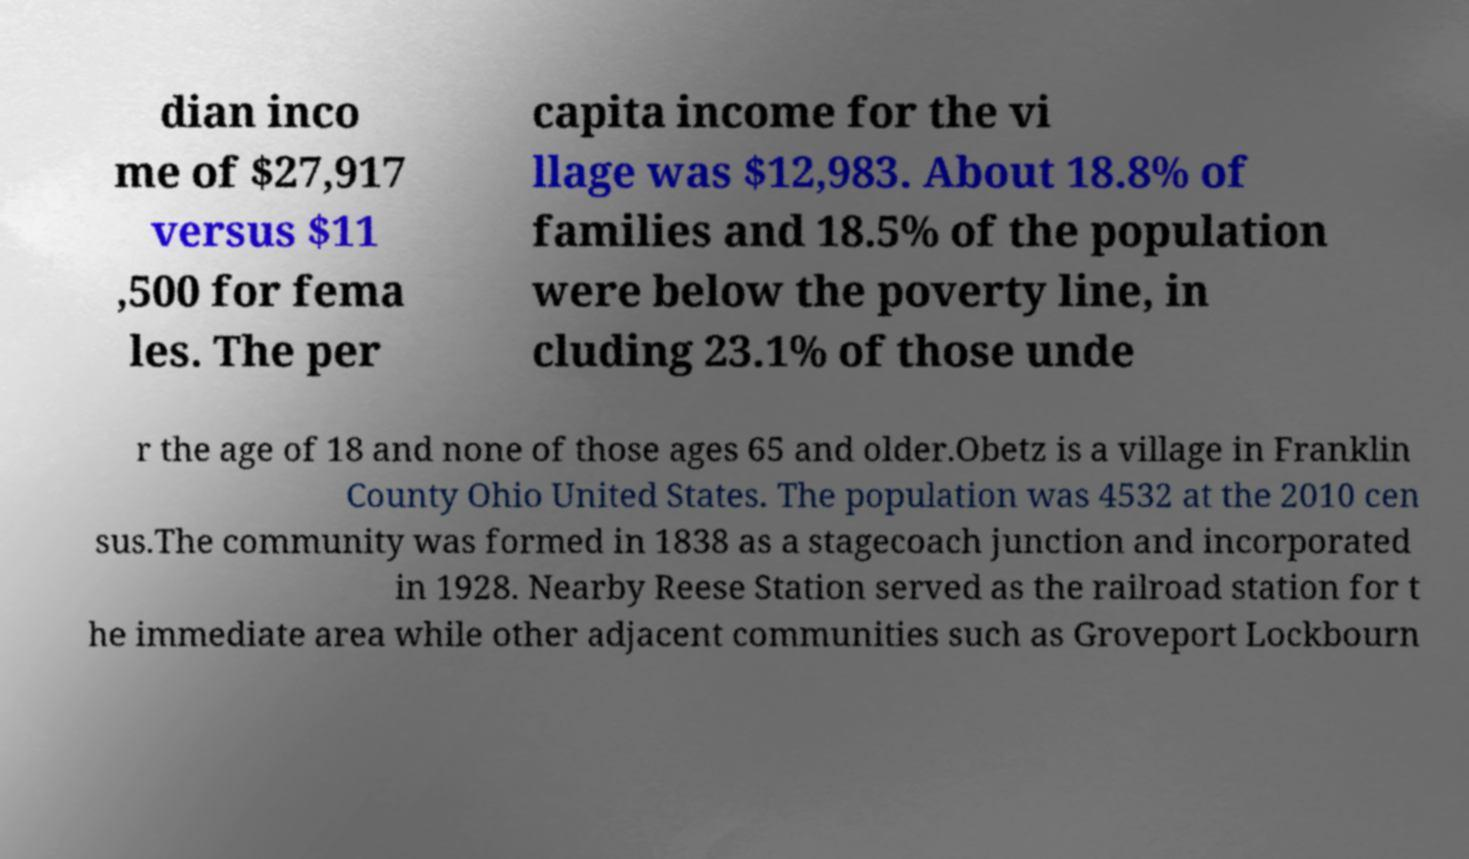Could you extract and type out the text from this image? dian inco me of $27,917 versus $11 ,500 for fema les. The per capita income for the vi llage was $12,983. About 18.8% of families and 18.5% of the population were below the poverty line, in cluding 23.1% of those unde r the age of 18 and none of those ages 65 and older.Obetz is a village in Franklin County Ohio United States. The population was 4532 at the 2010 cen sus.The community was formed in 1838 as a stagecoach junction and incorporated in 1928. Nearby Reese Station served as the railroad station for t he immediate area while other adjacent communities such as Groveport Lockbourn 